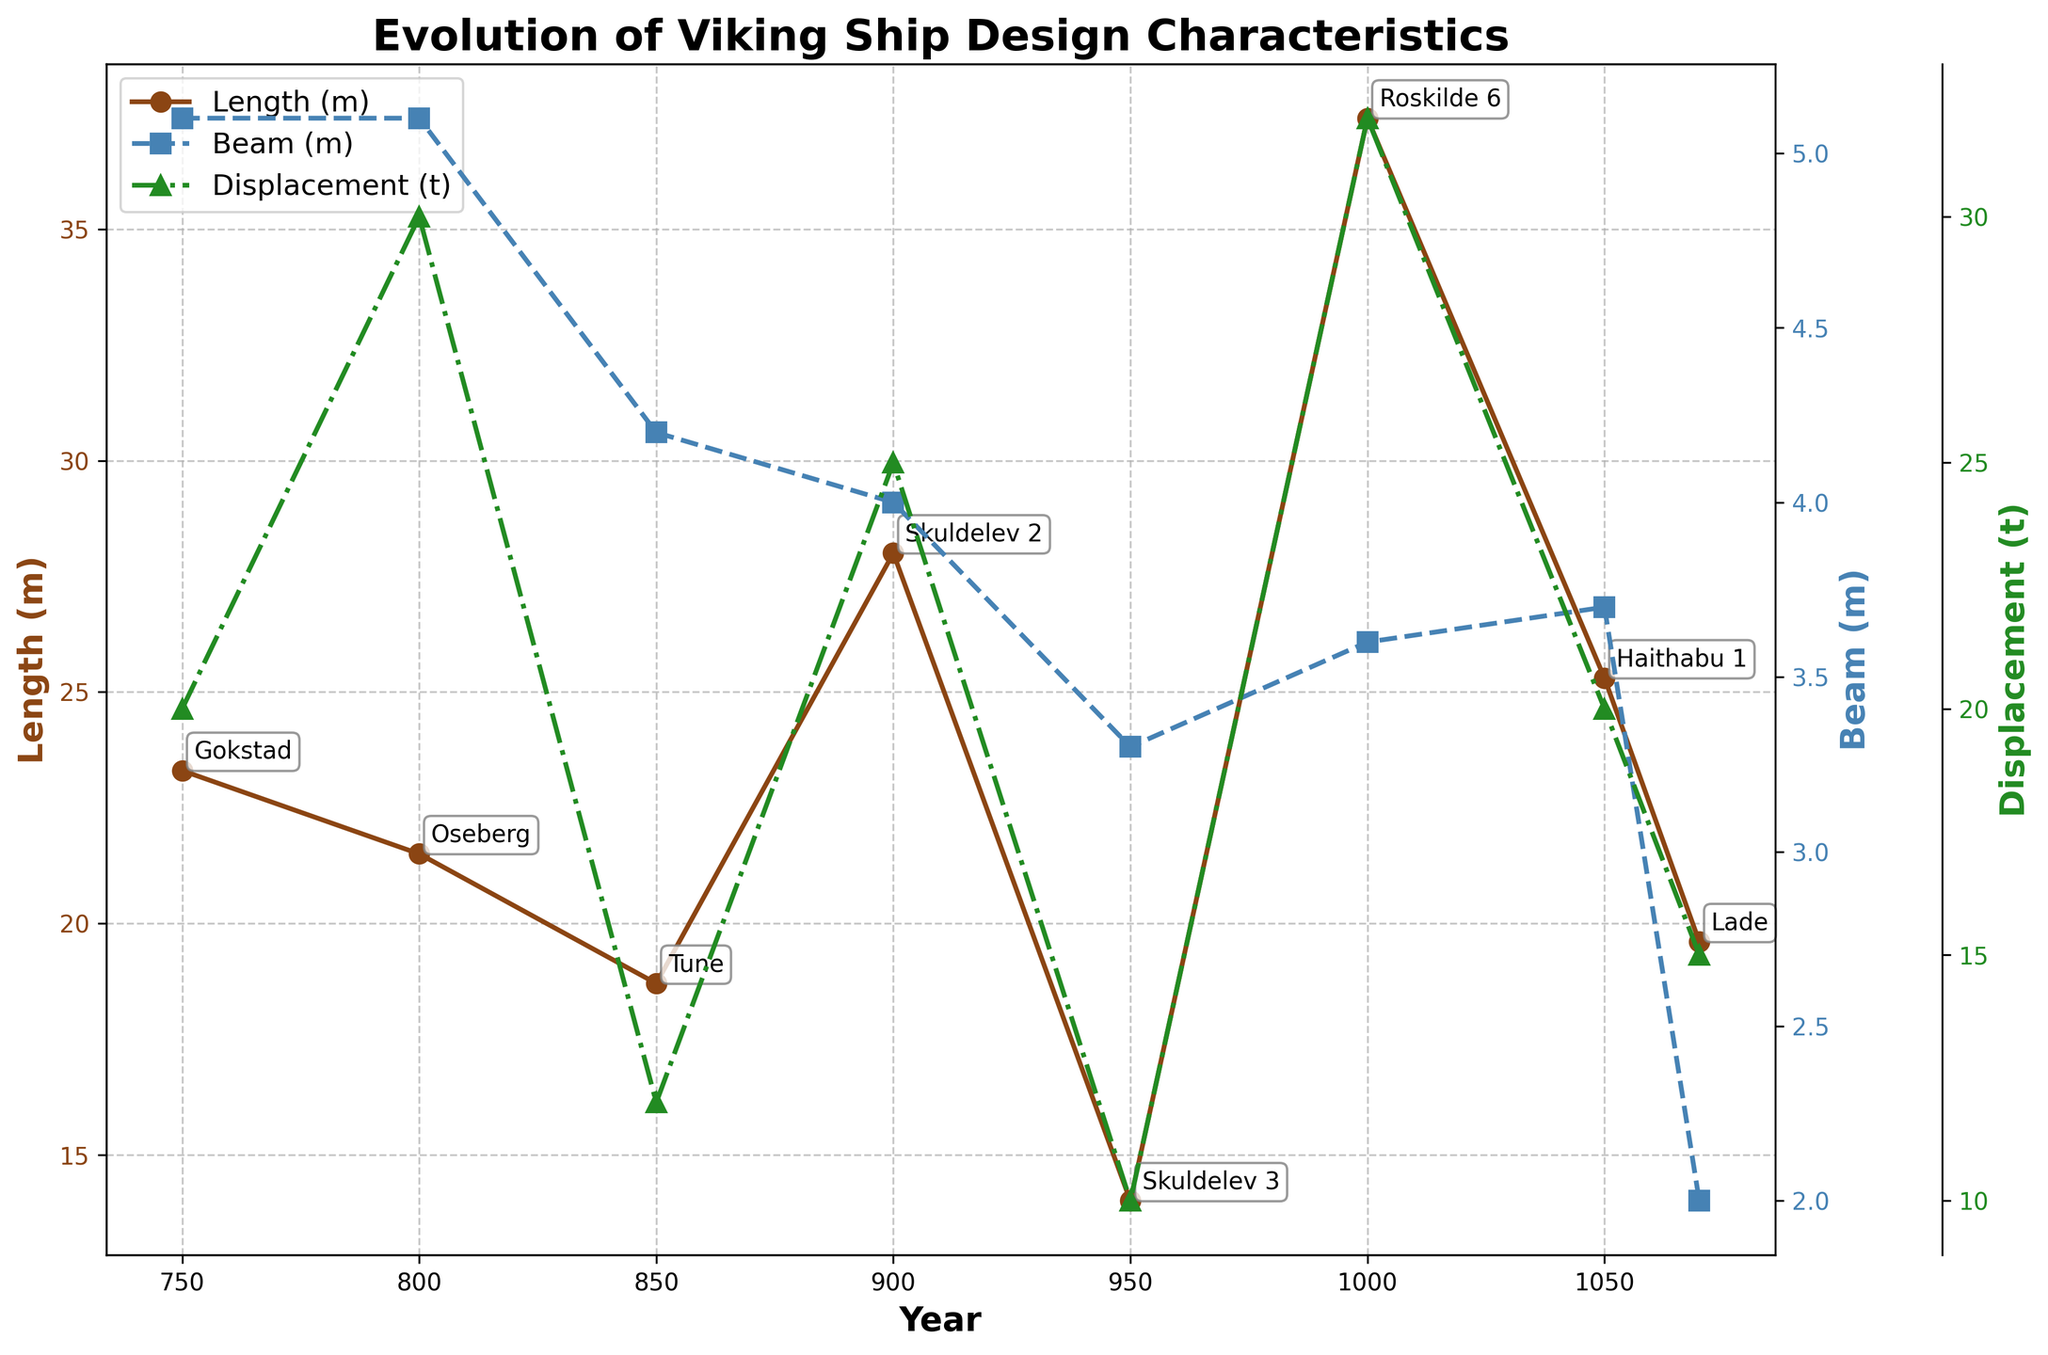what is the title of the plot? The title is prominently displayed at the top of the figure. It reads "Evolution of Viking Ship Design Characteristics".
Answer: Evolution of Viking Ship Design Characteristics How does the beam measurement change over the years 850 to 1000? To observe the change, look at the blue dashed line representing the Beam (m) values between 850 and 1000 on the x-axis. The beam value decreases slightly from 4.2 m in 850 to 3.6 m in 1000.
Answer: Decreases In which year did the Viking ship 'Roskilde 6' have the highest length? The annotation for the ship names helps in identifying 'Roskilde 6'. Cross-reference this with the year on the x-axis, which shows it was in the year 1000. This ship also has the highest length.
Answer: 1000 What is the average displacement of the ships after 900? Find the displacement values (green triangles) for the years 950, 1000, 1050, and 1070. The values are 10, 32, 20, and 15 respectively. The average is calculated as (10+32+20+15)/4.
Answer: 19.25 Which ship shows the greatest length and in what year? Identify the highest point on the brown line representing Length (m). The 'Roskilde 6' ship in the year 1000 has the greatest length of 37.4 m.
Answer: Roskilde 6, 1000 Compare the beam value of 'Lade' to 'Haithabu 1'. Which is larger and by how much? The annotation shows 'Lade' had a beam of 2.0 m in 1070 and 'Haithabu 1' had a beam of 3.7 m in 1050. Subtract the two values to find the difference.
Answer: Haithabu 1 by 1.7 m During which period does the displacement show the most variability? Look for the green triangular points, noting the years with the largest swings. Between 800 (30) and 850 (12), displacement drops significantly, and from 950 (10) to 1000 (32), it increases greatly. Compare these changes with other periods.
Answer: 950 to 1000 What is the range of lengths observed for all ships plotted? Identify the minimum and maximum values of Length (m) from the brown line. The smallest length is 14.0 m (Skuldelev 3) and the largest is 37.4 m (Roskilde 6). Calculate the range: 37.4 - 14.0.
Answer: 23.4 m Explain the trend in displacement values from 900 to 1070. Examine the green triangle line for displacement values from 900 onwards. The values start at 25 in 900, drop to 10 in 950, increase to 32 in 1000, decrease to 20 in 1050, and end at 15 in 1070. This shows high variability with significant fluctuations.
Answer: Highly variable Which year shows the maximum number of annotations for ship names and what are they? Count the number of annotations for each year. The year 900 has the most annotations with ships 'Skuldelev 2', 'Skuldelev 3', and 'Roskilde 6'.
Answer: 900, Skuldelev 2, Skuldelev 3, Roskilde 6 